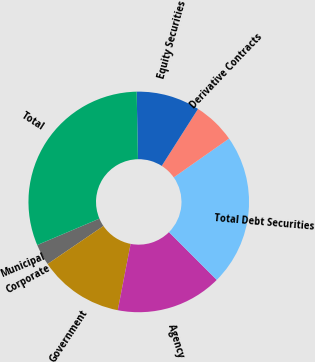<chart> <loc_0><loc_0><loc_500><loc_500><pie_chart><fcel>Municipal<fcel>Corporate<fcel>Government<fcel>Agency<fcel>Total Debt Securities<fcel>Derivative Contracts<fcel>Equity Securities<fcel>Total<nl><fcel>0.01%<fcel>3.12%<fcel>12.44%<fcel>15.55%<fcel>22.24%<fcel>6.23%<fcel>9.33%<fcel>31.09%<nl></chart> 